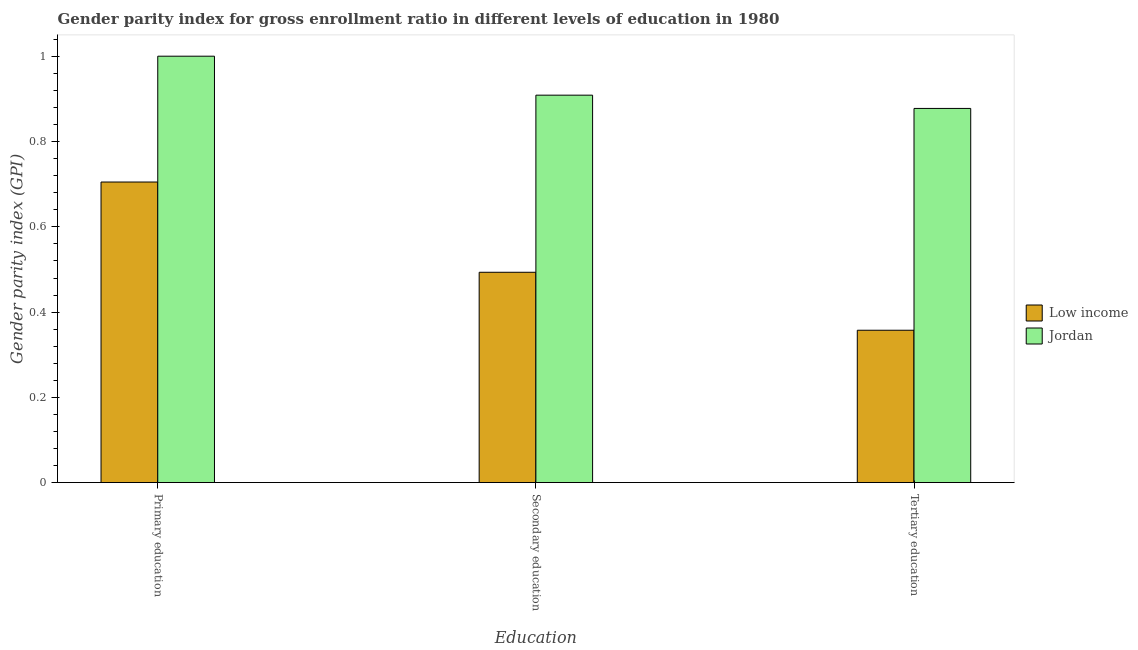How many groups of bars are there?
Provide a succinct answer. 3. Are the number of bars on each tick of the X-axis equal?
Keep it short and to the point. Yes. How many bars are there on the 1st tick from the left?
Ensure brevity in your answer.  2. What is the label of the 2nd group of bars from the left?
Make the answer very short. Secondary education. What is the gender parity index in secondary education in Low income?
Provide a succinct answer. 0.49. Across all countries, what is the maximum gender parity index in primary education?
Your response must be concise. 1. Across all countries, what is the minimum gender parity index in primary education?
Offer a terse response. 0.71. In which country was the gender parity index in tertiary education maximum?
Your answer should be compact. Jordan. In which country was the gender parity index in tertiary education minimum?
Provide a short and direct response. Low income. What is the total gender parity index in secondary education in the graph?
Your response must be concise. 1.4. What is the difference between the gender parity index in tertiary education in Jordan and that in Low income?
Offer a very short reply. 0.52. What is the difference between the gender parity index in secondary education in Low income and the gender parity index in tertiary education in Jordan?
Offer a terse response. -0.38. What is the average gender parity index in tertiary education per country?
Give a very brief answer. 0.62. What is the difference between the gender parity index in secondary education and gender parity index in primary education in Jordan?
Make the answer very short. -0.09. In how many countries, is the gender parity index in secondary education greater than 0.44 ?
Offer a very short reply. 2. What is the ratio of the gender parity index in secondary education in Low income to that in Jordan?
Ensure brevity in your answer.  0.54. Is the difference between the gender parity index in secondary education in Low income and Jordan greater than the difference between the gender parity index in primary education in Low income and Jordan?
Provide a succinct answer. No. What is the difference between the highest and the second highest gender parity index in primary education?
Make the answer very short. 0.3. What is the difference between the highest and the lowest gender parity index in secondary education?
Offer a terse response. 0.42. What does the 1st bar from the right in Secondary education represents?
Your answer should be very brief. Jordan. Is it the case that in every country, the sum of the gender parity index in primary education and gender parity index in secondary education is greater than the gender parity index in tertiary education?
Your answer should be compact. Yes. How many bars are there?
Your answer should be compact. 6. Does the graph contain any zero values?
Your answer should be very brief. No. Does the graph contain grids?
Keep it short and to the point. No. Where does the legend appear in the graph?
Make the answer very short. Center right. What is the title of the graph?
Give a very brief answer. Gender parity index for gross enrollment ratio in different levels of education in 1980. Does "El Salvador" appear as one of the legend labels in the graph?
Offer a very short reply. No. What is the label or title of the X-axis?
Keep it short and to the point. Education. What is the label or title of the Y-axis?
Your answer should be compact. Gender parity index (GPI). What is the Gender parity index (GPI) of Low income in Primary education?
Keep it short and to the point. 0.71. What is the Gender parity index (GPI) of Jordan in Primary education?
Your answer should be very brief. 1. What is the Gender parity index (GPI) of Low income in Secondary education?
Make the answer very short. 0.49. What is the Gender parity index (GPI) of Jordan in Secondary education?
Keep it short and to the point. 0.91. What is the Gender parity index (GPI) of Low income in Tertiary education?
Offer a very short reply. 0.36. What is the Gender parity index (GPI) of Jordan in Tertiary education?
Provide a succinct answer. 0.88. Across all Education, what is the maximum Gender parity index (GPI) of Low income?
Give a very brief answer. 0.71. Across all Education, what is the maximum Gender parity index (GPI) in Jordan?
Provide a short and direct response. 1. Across all Education, what is the minimum Gender parity index (GPI) of Low income?
Keep it short and to the point. 0.36. Across all Education, what is the minimum Gender parity index (GPI) of Jordan?
Give a very brief answer. 0.88. What is the total Gender parity index (GPI) of Low income in the graph?
Ensure brevity in your answer.  1.56. What is the total Gender parity index (GPI) in Jordan in the graph?
Keep it short and to the point. 2.79. What is the difference between the Gender parity index (GPI) in Low income in Primary education and that in Secondary education?
Ensure brevity in your answer.  0.21. What is the difference between the Gender parity index (GPI) in Jordan in Primary education and that in Secondary education?
Make the answer very short. 0.09. What is the difference between the Gender parity index (GPI) of Low income in Primary education and that in Tertiary education?
Provide a short and direct response. 0.35. What is the difference between the Gender parity index (GPI) of Jordan in Primary education and that in Tertiary education?
Keep it short and to the point. 0.12. What is the difference between the Gender parity index (GPI) of Low income in Secondary education and that in Tertiary education?
Offer a terse response. 0.14. What is the difference between the Gender parity index (GPI) in Jordan in Secondary education and that in Tertiary education?
Offer a very short reply. 0.03. What is the difference between the Gender parity index (GPI) in Low income in Primary education and the Gender parity index (GPI) in Jordan in Secondary education?
Offer a very short reply. -0.2. What is the difference between the Gender parity index (GPI) in Low income in Primary education and the Gender parity index (GPI) in Jordan in Tertiary education?
Provide a succinct answer. -0.17. What is the difference between the Gender parity index (GPI) in Low income in Secondary education and the Gender parity index (GPI) in Jordan in Tertiary education?
Make the answer very short. -0.38. What is the average Gender parity index (GPI) in Low income per Education?
Your response must be concise. 0.52. What is the average Gender parity index (GPI) of Jordan per Education?
Provide a short and direct response. 0.93. What is the difference between the Gender parity index (GPI) of Low income and Gender parity index (GPI) of Jordan in Primary education?
Offer a terse response. -0.3. What is the difference between the Gender parity index (GPI) of Low income and Gender parity index (GPI) of Jordan in Secondary education?
Offer a terse response. -0.42. What is the difference between the Gender parity index (GPI) in Low income and Gender parity index (GPI) in Jordan in Tertiary education?
Provide a succinct answer. -0.52. What is the ratio of the Gender parity index (GPI) of Low income in Primary education to that in Secondary education?
Offer a terse response. 1.43. What is the ratio of the Gender parity index (GPI) of Jordan in Primary education to that in Secondary education?
Ensure brevity in your answer.  1.1. What is the ratio of the Gender parity index (GPI) of Low income in Primary education to that in Tertiary education?
Ensure brevity in your answer.  1.97. What is the ratio of the Gender parity index (GPI) in Jordan in Primary education to that in Tertiary education?
Offer a very short reply. 1.14. What is the ratio of the Gender parity index (GPI) of Low income in Secondary education to that in Tertiary education?
Your answer should be very brief. 1.38. What is the ratio of the Gender parity index (GPI) of Jordan in Secondary education to that in Tertiary education?
Ensure brevity in your answer.  1.04. What is the difference between the highest and the second highest Gender parity index (GPI) of Low income?
Provide a short and direct response. 0.21. What is the difference between the highest and the second highest Gender parity index (GPI) in Jordan?
Provide a short and direct response. 0.09. What is the difference between the highest and the lowest Gender parity index (GPI) of Low income?
Make the answer very short. 0.35. What is the difference between the highest and the lowest Gender parity index (GPI) in Jordan?
Offer a terse response. 0.12. 